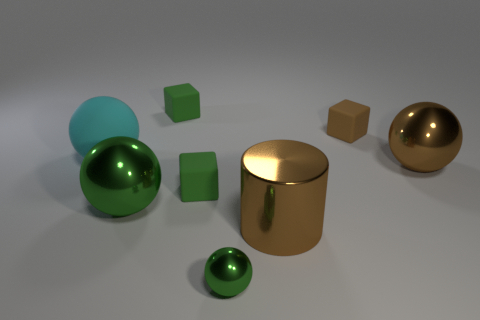Subtract 2 spheres. How many spheres are left? 2 Add 1 large yellow shiny spheres. How many objects exist? 9 Subtract all blue balls. Subtract all red cubes. How many balls are left? 4 Subtract all cylinders. How many objects are left? 7 Add 7 brown balls. How many brown balls exist? 8 Subtract 1 brown blocks. How many objects are left? 7 Subtract all tiny green rubber cubes. Subtract all cyan objects. How many objects are left? 5 Add 5 big brown objects. How many big brown objects are left? 7 